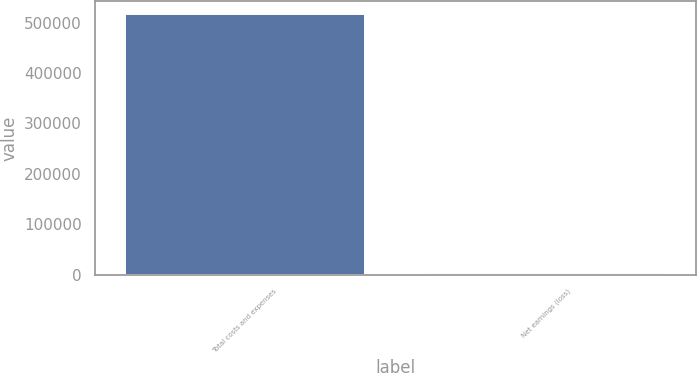Convert chart to OTSL. <chart><loc_0><loc_0><loc_500><loc_500><bar_chart><fcel>Total costs and expenses<fcel>Net earnings (loss)<nl><fcel>516747<fcel>2657<nl></chart> 